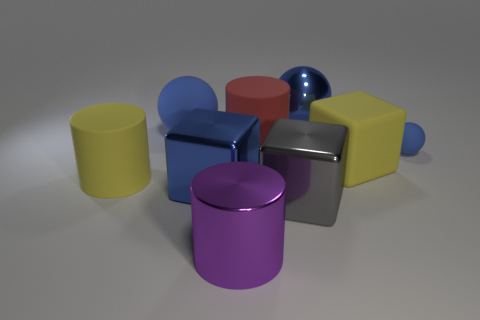Subtract all big metal cubes. How many cubes are left? 1 Subtract all balls. How many objects are left? 6 Subtract all blue cubes. How many cubes are left? 2 Subtract 1 balls. How many balls are left? 2 Add 5 metal cubes. How many metal cubes exist? 7 Subtract 3 blue balls. How many objects are left? 6 Subtract all gray blocks. Subtract all purple spheres. How many blocks are left? 2 Subtract all green spheres. How many cyan cylinders are left? 0 Subtract all green metallic cylinders. Subtract all tiny matte balls. How many objects are left? 8 Add 2 large blocks. How many large blocks are left? 5 